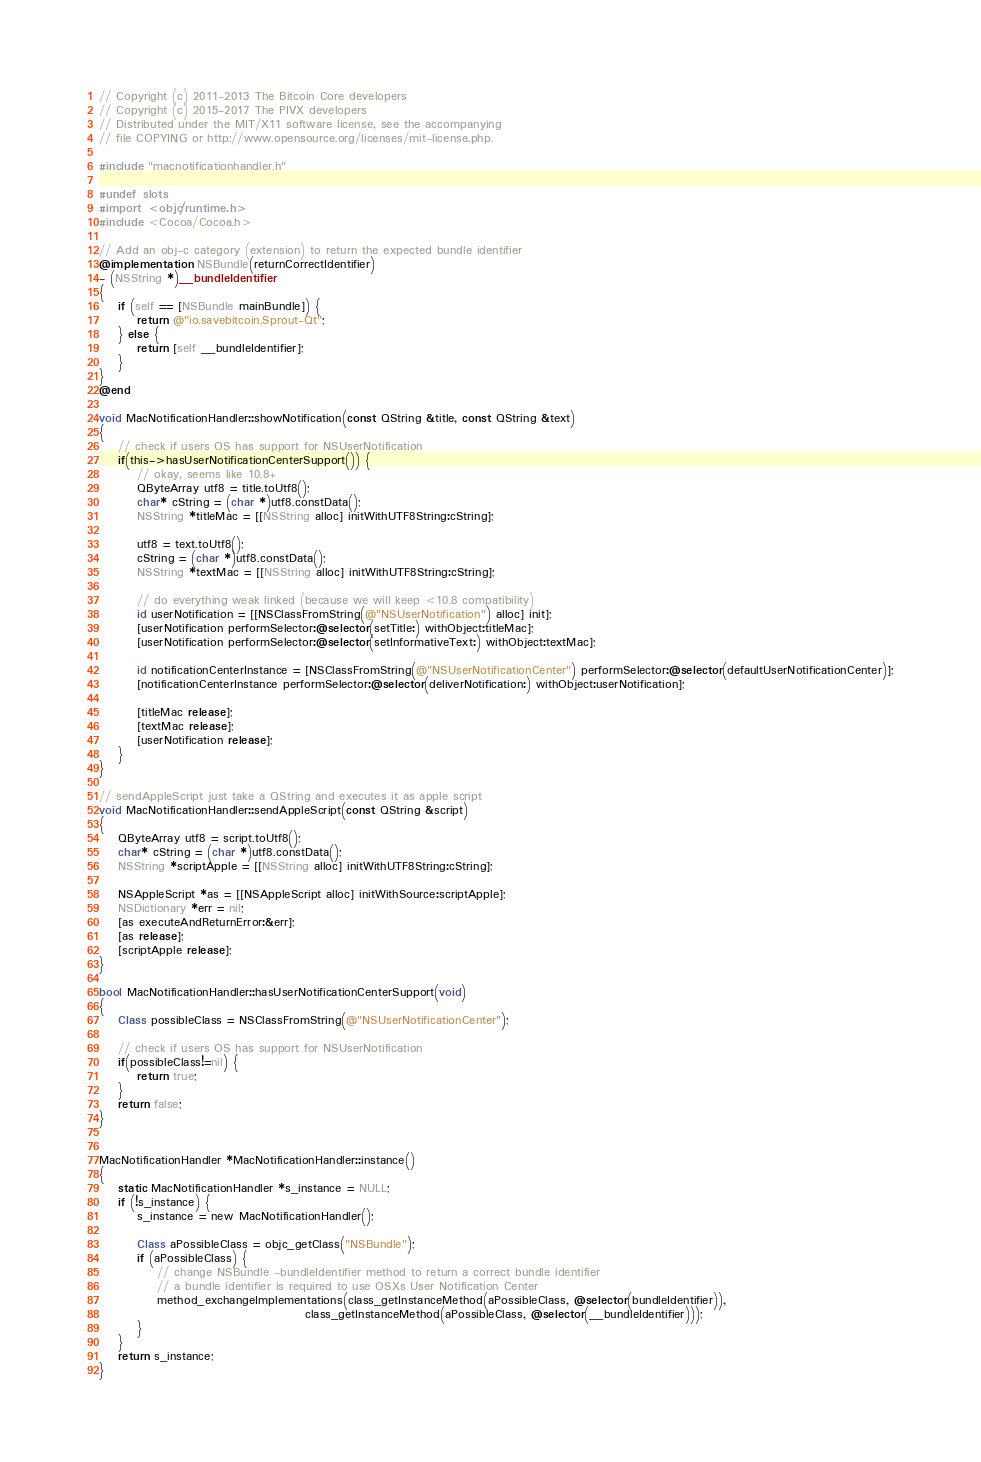Convert code to text. <code><loc_0><loc_0><loc_500><loc_500><_ObjectiveC_>// Copyright (c) 2011-2013 The Bitcoin Core developers
// Copyright (c) 2015-2017 The PIVX developers
// Distributed under the MIT/X11 software license, see the accompanying
// file COPYING or http://www.opensource.org/licenses/mit-license.php.

#include "macnotificationhandler.h"

#undef slots
#import <objc/runtime.h>
#include <Cocoa/Cocoa.h>

// Add an obj-c category (extension) to return the expected bundle identifier
@implementation NSBundle(returnCorrectIdentifier)
- (NSString *)__bundleIdentifier
{
    if (self == [NSBundle mainBundle]) {
        return @"io.savebitcoin.Sprout-Qt";
    } else {
        return [self __bundleIdentifier];
    }
}
@end

void MacNotificationHandler::showNotification(const QString &title, const QString &text)
{
    // check if users OS has support for NSUserNotification
    if(this->hasUserNotificationCenterSupport()) {
        // okay, seems like 10.8+
        QByteArray utf8 = title.toUtf8();
        char* cString = (char *)utf8.constData();
        NSString *titleMac = [[NSString alloc] initWithUTF8String:cString];

        utf8 = text.toUtf8();
        cString = (char *)utf8.constData();
        NSString *textMac = [[NSString alloc] initWithUTF8String:cString];

        // do everything weak linked (because we will keep <10.8 compatibility)
        id userNotification = [[NSClassFromString(@"NSUserNotification") alloc] init];
        [userNotification performSelector:@selector(setTitle:) withObject:titleMac];
        [userNotification performSelector:@selector(setInformativeText:) withObject:textMac];

        id notificationCenterInstance = [NSClassFromString(@"NSUserNotificationCenter") performSelector:@selector(defaultUserNotificationCenter)];
        [notificationCenterInstance performSelector:@selector(deliverNotification:) withObject:userNotification];

        [titleMac release];
        [textMac release];
        [userNotification release];
    }
}

// sendAppleScript just take a QString and executes it as apple script
void MacNotificationHandler::sendAppleScript(const QString &script)
{
    QByteArray utf8 = script.toUtf8();
    char* cString = (char *)utf8.constData();
    NSString *scriptApple = [[NSString alloc] initWithUTF8String:cString];

    NSAppleScript *as = [[NSAppleScript alloc] initWithSource:scriptApple];
    NSDictionary *err = nil;
    [as executeAndReturnError:&err];
    [as release];
    [scriptApple release];
}

bool MacNotificationHandler::hasUserNotificationCenterSupport(void)
{
    Class possibleClass = NSClassFromString(@"NSUserNotificationCenter");

    // check if users OS has support for NSUserNotification
    if(possibleClass!=nil) {
        return true;
    }
    return false;
}


MacNotificationHandler *MacNotificationHandler::instance()
{
    static MacNotificationHandler *s_instance = NULL;
    if (!s_instance) {
        s_instance = new MacNotificationHandler();
        
        Class aPossibleClass = objc_getClass("NSBundle");
        if (aPossibleClass) {
            // change NSBundle -bundleIdentifier method to return a correct bundle identifier
            // a bundle identifier is required to use OSXs User Notification Center
            method_exchangeImplementations(class_getInstanceMethod(aPossibleClass, @selector(bundleIdentifier)),
                                           class_getInstanceMethod(aPossibleClass, @selector(__bundleIdentifier)));
        }
    }
    return s_instance;
}
</code> 